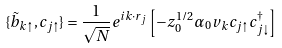<formula> <loc_0><loc_0><loc_500><loc_500>\{ \tilde { b } _ { { k } \uparrow } , c _ { j \uparrow } \} = \frac { 1 } { \sqrt { N } } e ^ { i { k } \cdot { r } _ { j } } \left [ - z _ { 0 } ^ { 1 / 2 } \alpha _ { 0 } v _ { k } c _ { j \uparrow } c _ { j \downarrow } ^ { \dagger } \right ]</formula> 